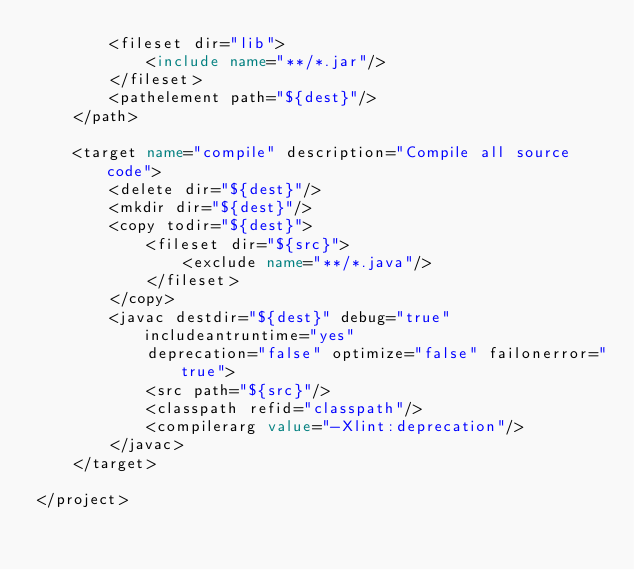Convert code to text. <code><loc_0><loc_0><loc_500><loc_500><_XML_>		<fileset dir="lib">
			<include name="**/*.jar"/>
		</fileset>
		<pathelement path="${dest}"/>
	</path>

	<target name="compile" description="Compile all source code">
		<delete dir="${dest}"/>
		<mkdir dir="${dest}"/>
		<copy todir="${dest}">
			<fileset dir="${src}">
				<exclude name="**/*.java"/>
			</fileset>		
		</copy>
		<javac destdir="${dest}" debug="true" includeantruntime="yes"
			deprecation="false" optimize="false" failonerror="true">
			<src path="${src}"/>
			<classpath refid="classpath"/>
			<compilerarg value="-Xlint:deprecation"/>
		</javac>
	</target>

</project></code> 